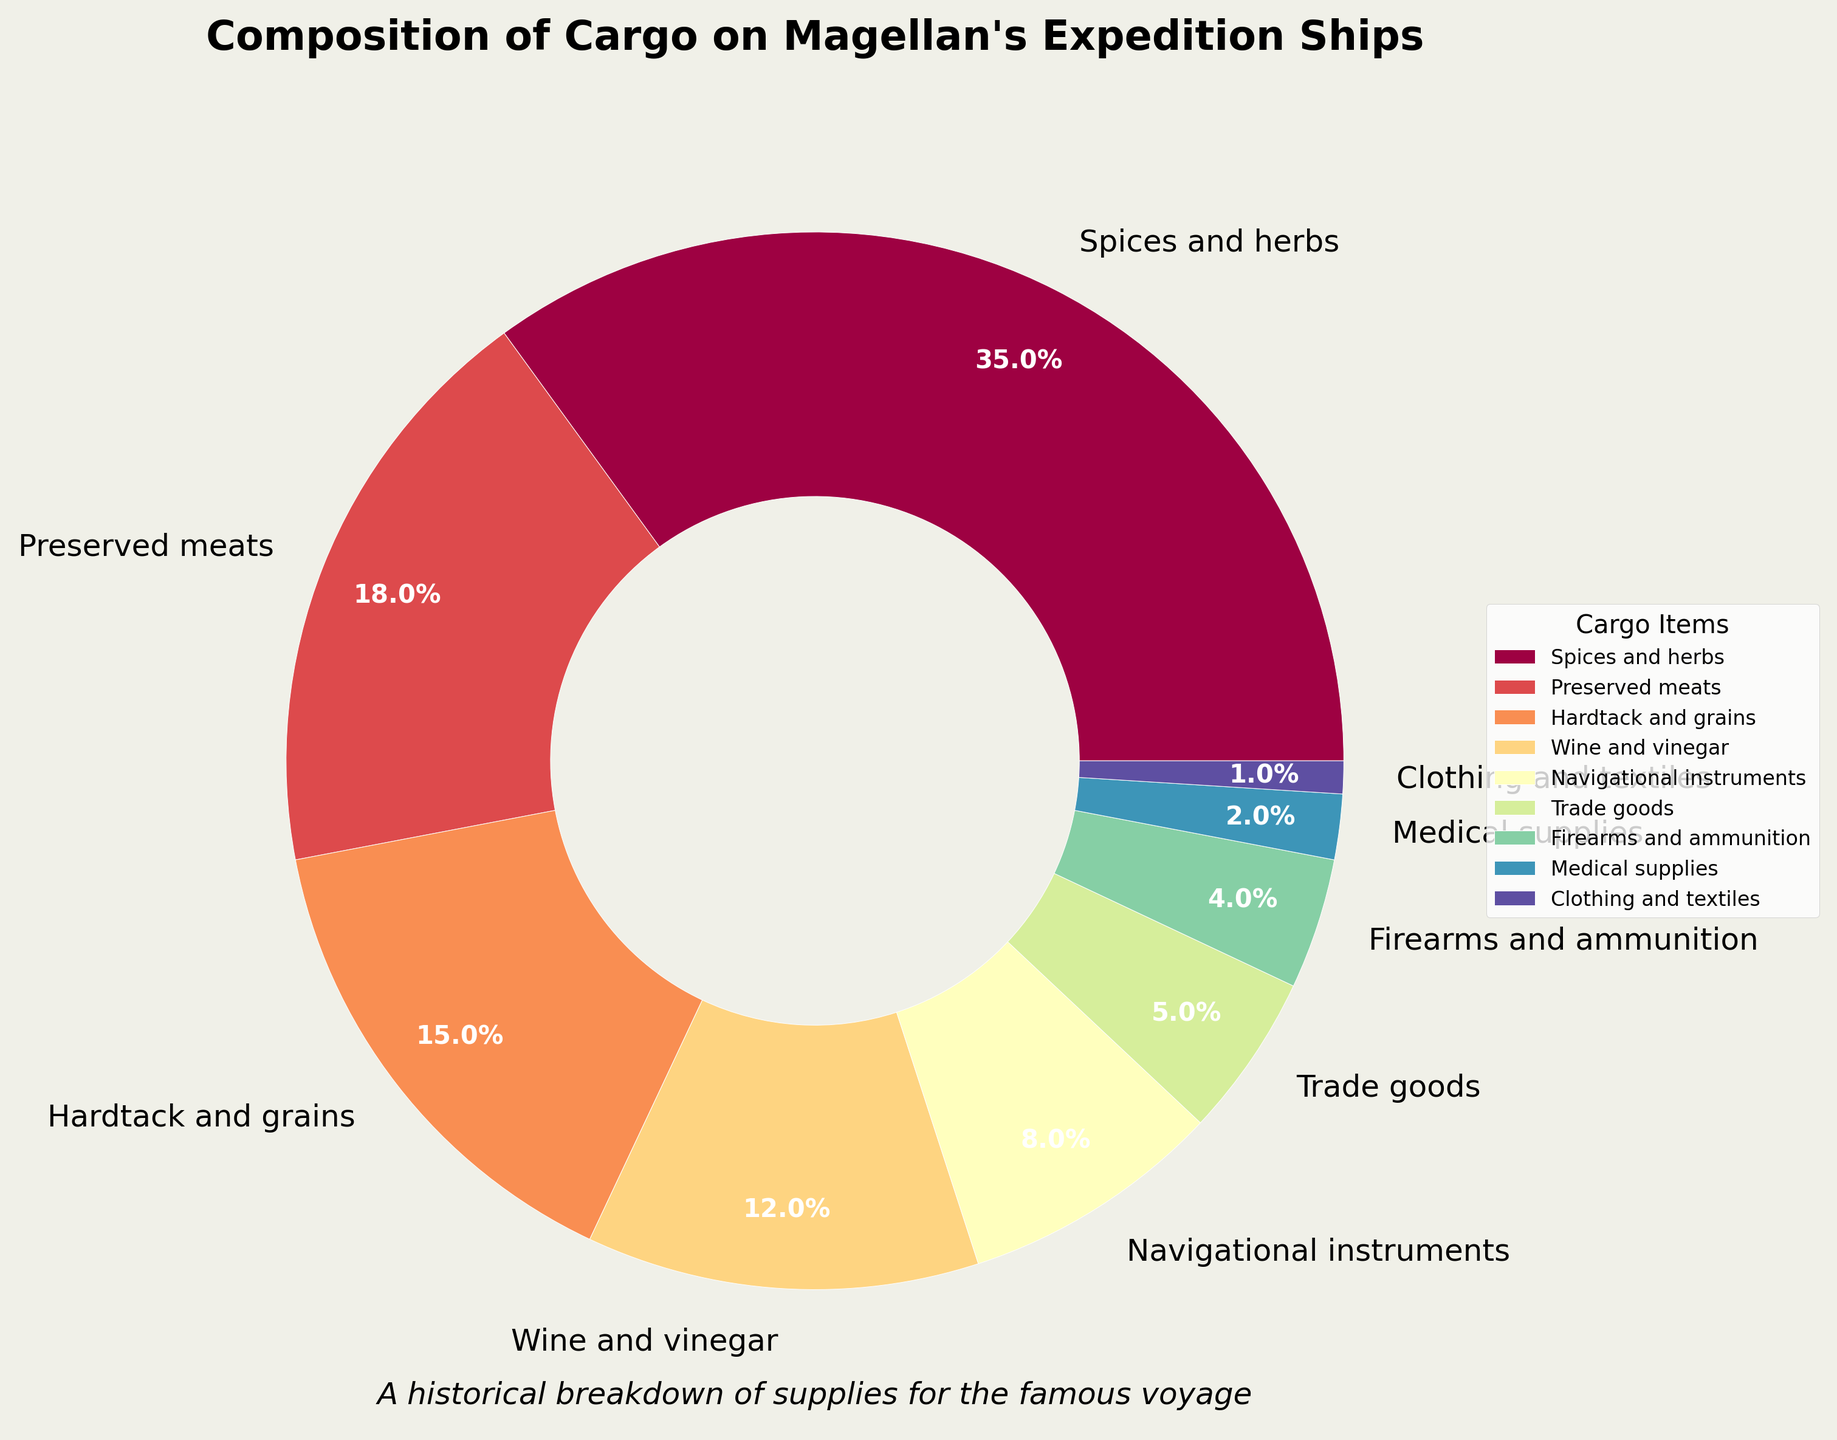What's the most abundant type of cargo on Magellan's expedition ships? The pie chart shows the distribution of different cargo items. By looking at the largest segment, we see that the most abundant cargo is "Spices and herbs" at 35%.
Answer: Spices and herbs What two items combined account for over half of the cargo? To determine which items combined constitute over 50%, we start with the largest percentages and sum them. "Spices and herbs" (35%) and "Preserved meats" (18%) together make 53%, which is over half.
Answer: Spices and herbs and Preserved meats Which item is exactly double the percentage of medical supplies? Medical supplies have a percentage of 2%. Double this value would be 4%. From the chart, "Firearms and ammunition" is listed at 4%.
Answer: Firearms and ammunition What is the total percentage of all navigational and medical supplies combined? The pie chart lists "Navigational instruments" at 8% and "Medical supplies" at 2%. Their total is 8% + 2% = 10%.
Answer: 10% Compare the quantities of wine and vinegar to hardtack and grains. Which one is higher? According to the chart, "Wine and vinegar" is 12% and "Hardtack and grains" is 15%. Since 15% > 12%, hardtack and grains have a higher percentage.
Answer: Hardtack and grains Which category is less than or equal to 5% of the cargo, and name them? Scanning the pie chart, we see "Trade goods" (5%), "Firearms and ammunition" (4%), "Medical supplies" (2%), and "Clothing and textiles" (1%) all are 5% or less.
Answer: Trade goods, Firearms and ammunition, Medical supplies, Clothing and textiles What percentage of cargo is not dedicated to food and drink (sum of spices and herbs, preserved meats, hardtack and grains, wine and vinegar)? First, sum up the food and drink categories: 35% (Spices and herbs) + 18% (Preserved meats) + 15% (Hardtack and grains) + 12% (Wine and vinegar) = 80%. Therefore, 100% - 80% = 20% is not dedicated to food and drink.
Answer: 20% What percentage do trade goods and navigational instruments together represent? From the chart, "Trade goods" is 5% and "Navigational instruments" is 8%. Their combined percentage is 5% + 8% = 13%.
Answer: 13% 